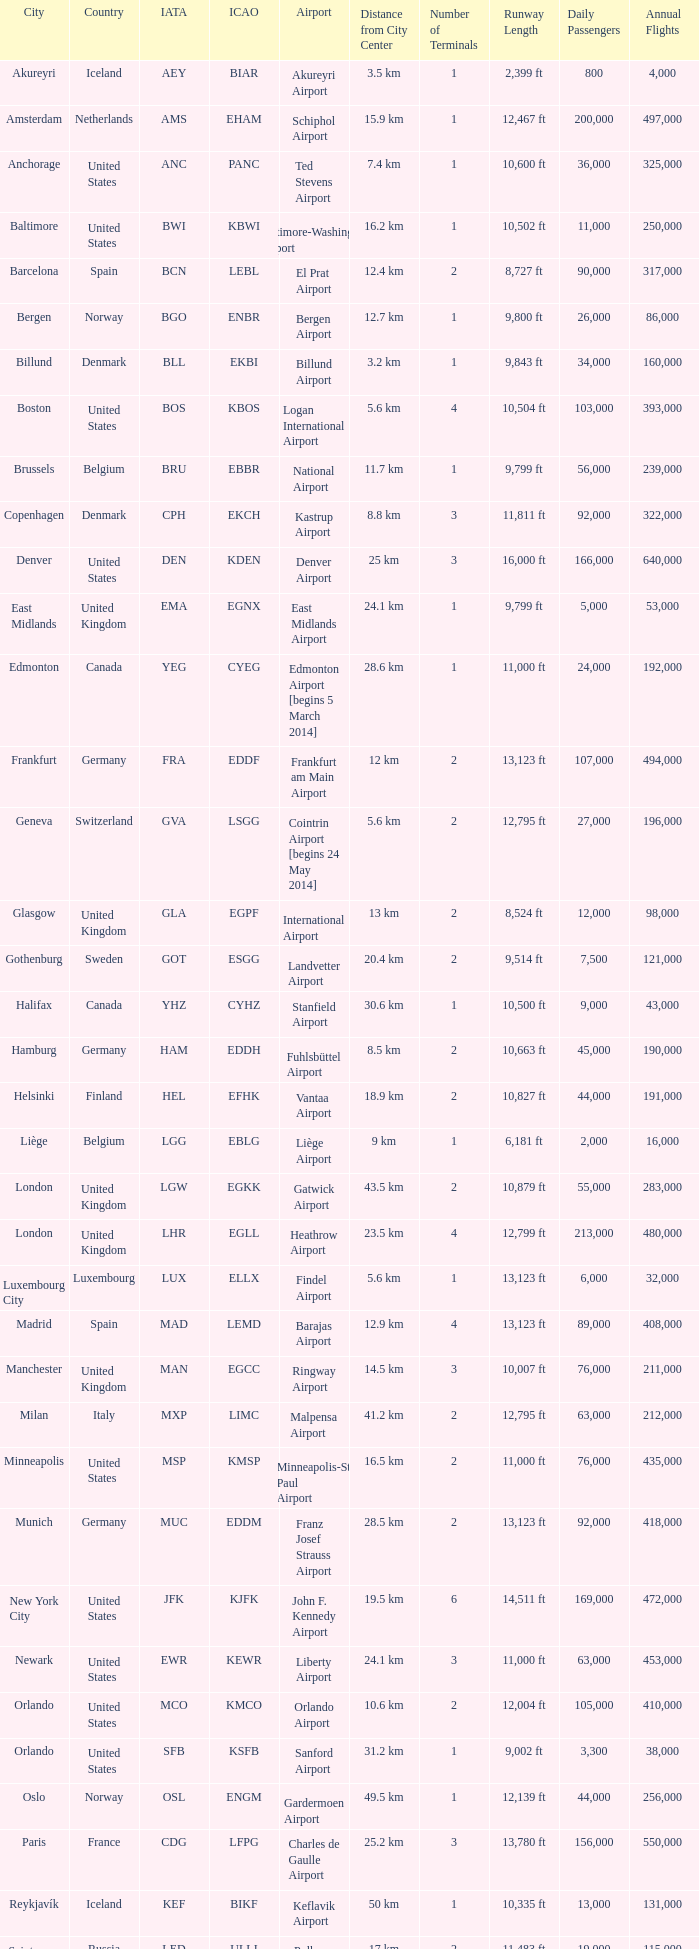What is the IATA OF Akureyri? AEY. 